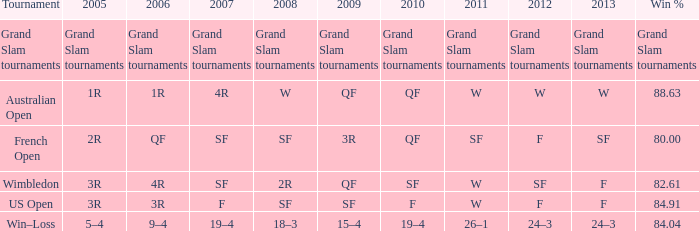Which Tournament has a 2007 of 19–4? Win–Loss. 